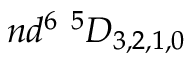<formula> <loc_0><loc_0><loc_500><loc_500>n d ^ { 6 ^ { 5 } D _ { 3 , 2 , 1 , 0 }</formula> 